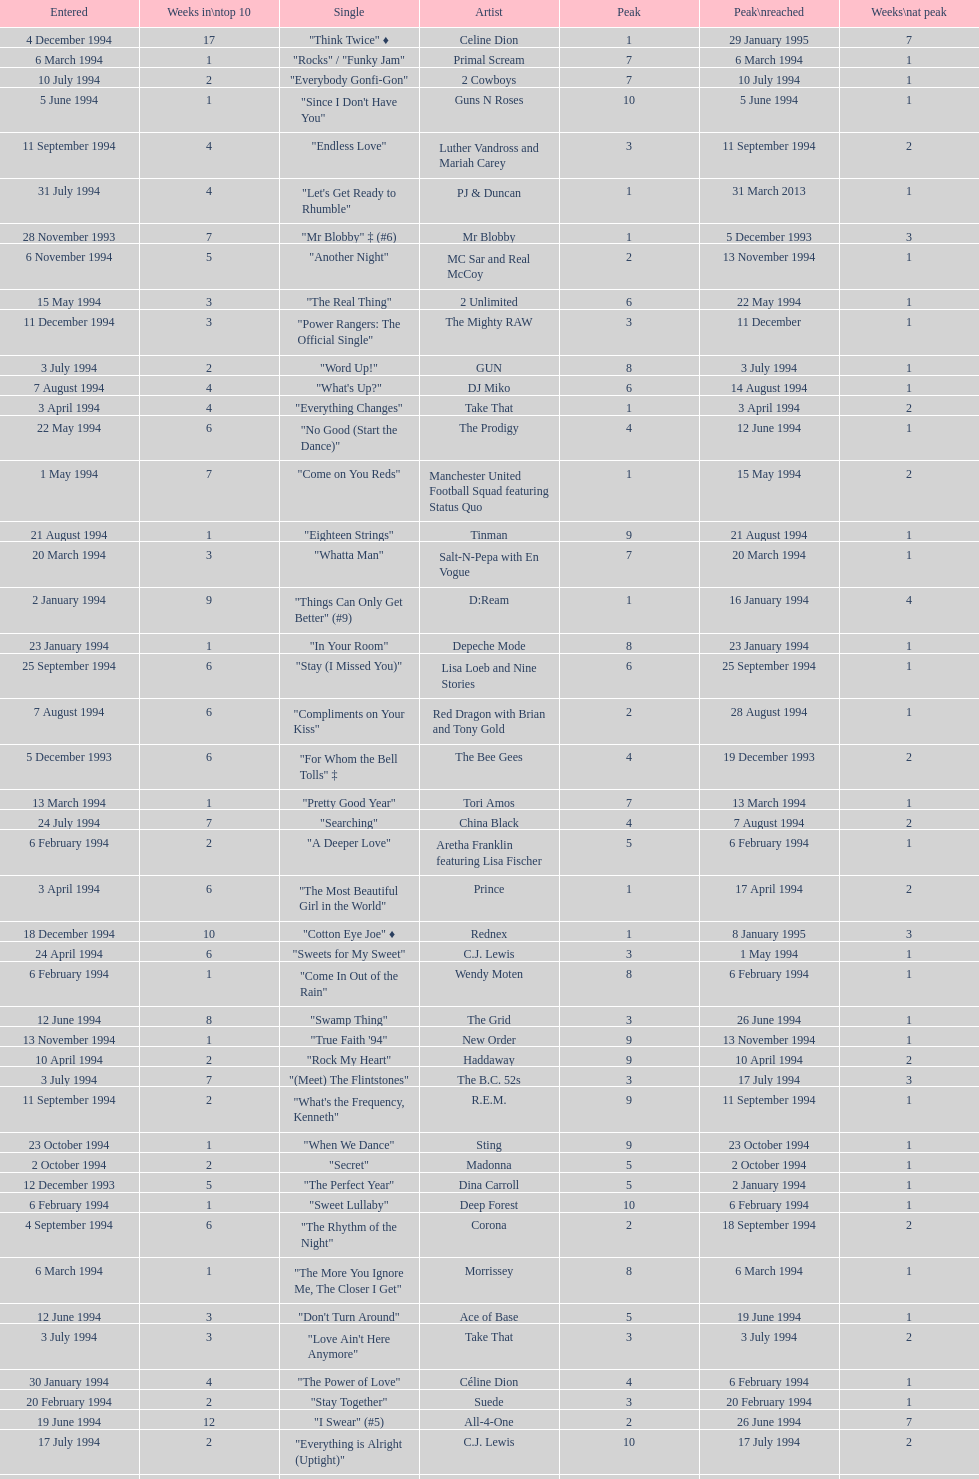Which artist came on the list after oasis? Tinman. 